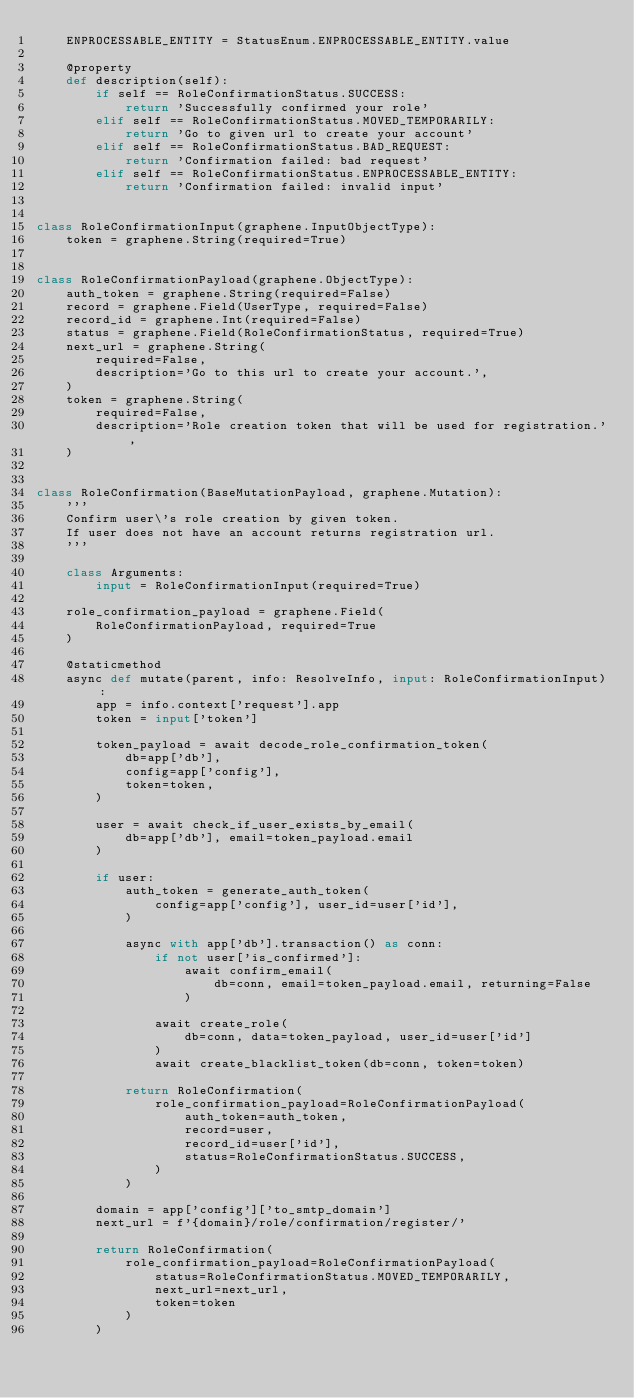Convert code to text. <code><loc_0><loc_0><loc_500><loc_500><_Python_>    ENPROCESSABLE_ENTITY = StatusEnum.ENPROCESSABLE_ENTITY.value

    @property
    def description(self):
        if self == RoleConfirmationStatus.SUCCESS:
            return 'Successfully confirmed your role'
        elif self == RoleConfirmationStatus.MOVED_TEMPORARILY:
            return 'Go to given url to create your account'
        elif self == RoleConfirmationStatus.BAD_REQUEST:
            return 'Confirmation failed: bad request'
        elif self == RoleConfirmationStatus.ENPROCESSABLE_ENTITY:
            return 'Confirmation failed: invalid input'


class RoleConfirmationInput(graphene.InputObjectType):
    token = graphene.String(required=True)


class RoleConfirmationPayload(graphene.ObjectType):
    auth_token = graphene.String(required=False)
    record = graphene.Field(UserType, required=False)
    record_id = graphene.Int(required=False)
    status = graphene.Field(RoleConfirmationStatus, required=True)
    next_url = graphene.String(
        required=False,
        description='Go to this url to create your account.',
    )
    token = graphene.String(
        required=False,
        description='Role creation token that will be used for registration.',
    )


class RoleConfirmation(BaseMutationPayload, graphene.Mutation):
    '''
    Confirm user\'s role creation by given token.
    If user does not have an account returns registration url.
    '''

    class Arguments:
        input = RoleConfirmationInput(required=True)

    role_confirmation_payload = graphene.Field(
        RoleConfirmationPayload, required=True
    )

    @staticmethod
    async def mutate(parent, info: ResolveInfo, input: RoleConfirmationInput):
        app = info.context['request'].app
        token = input['token']

        token_payload = await decode_role_confirmation_token(
            db=app['db'],
            config=app['config'],
            token=token,
        )

        user = await check_if_user_exists_by_email(
            db=app['db'], email=token_payload.email
        )

        if user:
            auth_token = generate_auth_token(
                config=app['config'], user_id=user['id'],
            )

            async with app['db'].transaction() as conn:
                if not user['is_confirmed']:
                    await confirm_email(
                        db=conn, email=token_payload.email, returning=False
                    )

                await create_role(
                    db=conn, data=token_payload, user_id=user['id']
                )
                await create_blacklist_token(db=conn, token=token)

            return RoleConfirmation(
                role_confirmation_payload=RoleConfirmationPayload(
                    auth_token=auth_token,
                    record=user,
                    record_id=user['id'],
                    status=RoleConfirmationStatus.SUCCESS,
                )
            )

        domain = app['config']['to_smtp_domain']
        next_url = f'{domain}/role/confirmation/register/'

        return RoleConfirmation(
            role_confirmation_payload=RoleConfirmationPayload(
                status=RoleConfirmationStatus.MOVED_TEMPORARILY,
                next_url=next_url,
                token=token
            )
        )
</code> 